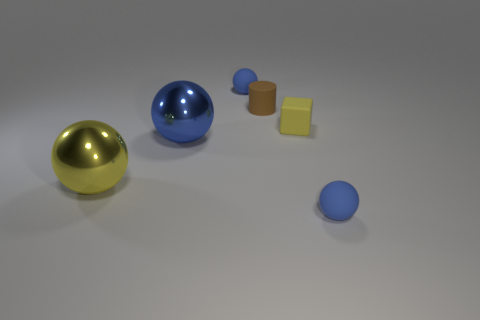Imagine this is a scene from a science fiction movie. What purpose might these objects serve in such a setting? In a science fiction setting, these objects could be part of a high-tech laboratory or an alien environment. The spheres might be energy orbs, the cylinders could contain rare materials or serve as power cells, and the flat objects might be data storage devices or communication tablets. The differing textures and appearances give a sense that each object has a unique function or is made of a distinct alien material. 